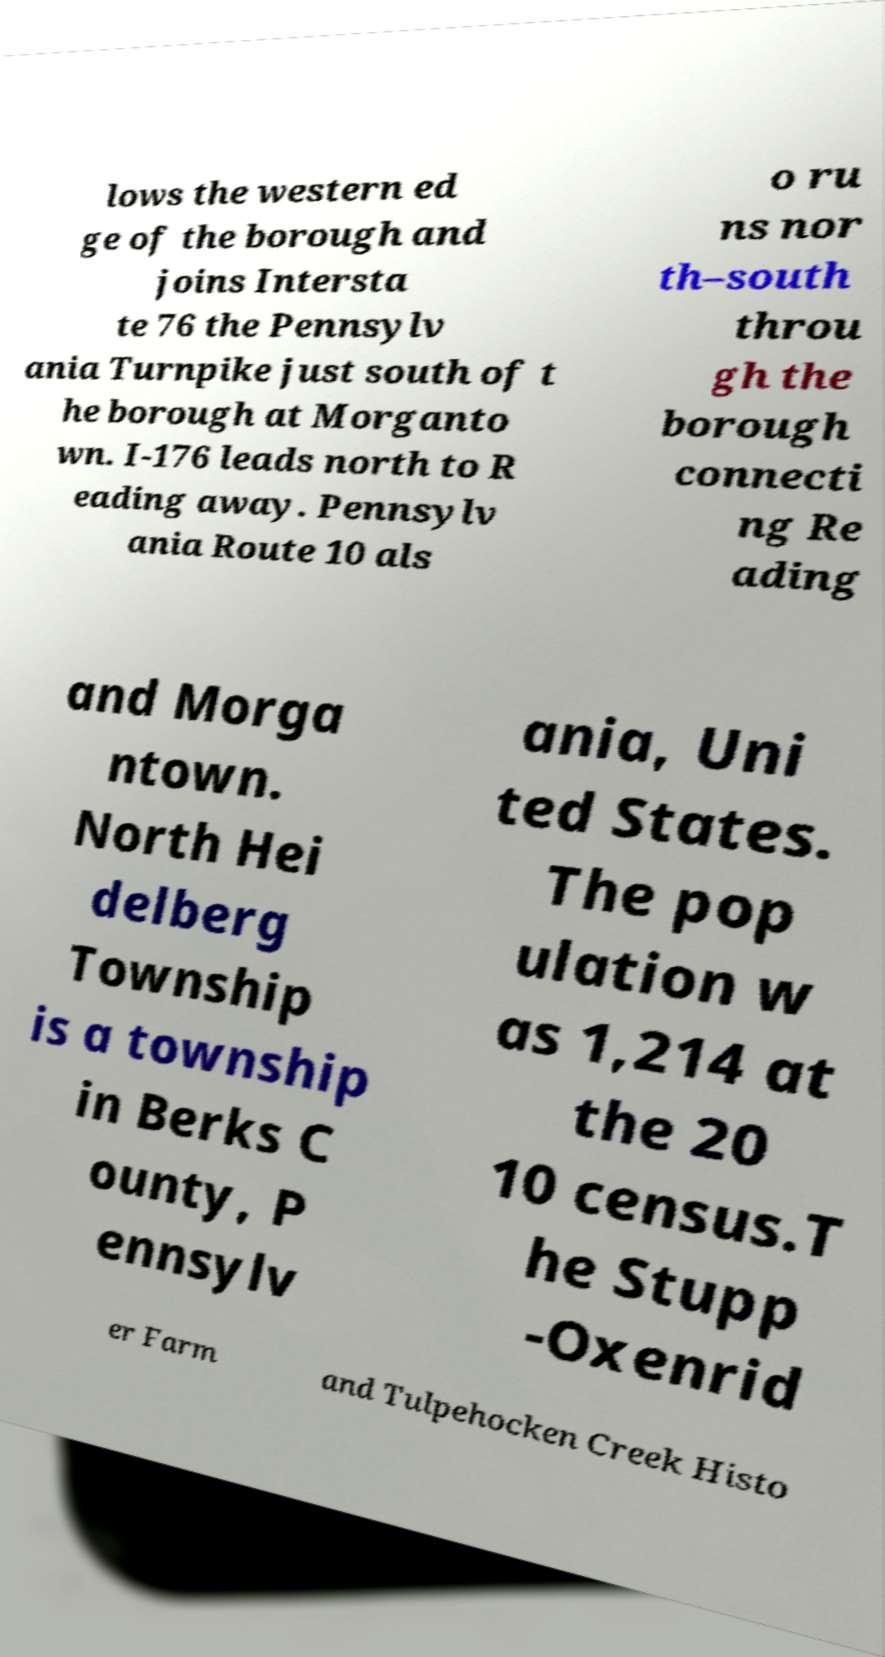For documentation purposes, I need the text within this image transcribed. Could you provide that? lows the western ed ge of the borough and joins Intersta te 76 the Pennsylv ania Turnpike just south of t he borough at Morganto wn. I-176 leads north to R eading away. Pennsylv ania Route 10 als o ru ns nor th–south throu gh the borough connecti ng Re ading and Morga ntown. North Hei delberg Township is a township in Berks C ounty, P ennsylv ania, Uni ted States. The pop ulation w as 1,214 at the 20 10 census.T he Stupp -Oxenrid er Farm and Tulpehocken Creek Histo 